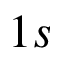<formula> <loc_0><loc_0><loc_500><loc_500>1 s</formula> 